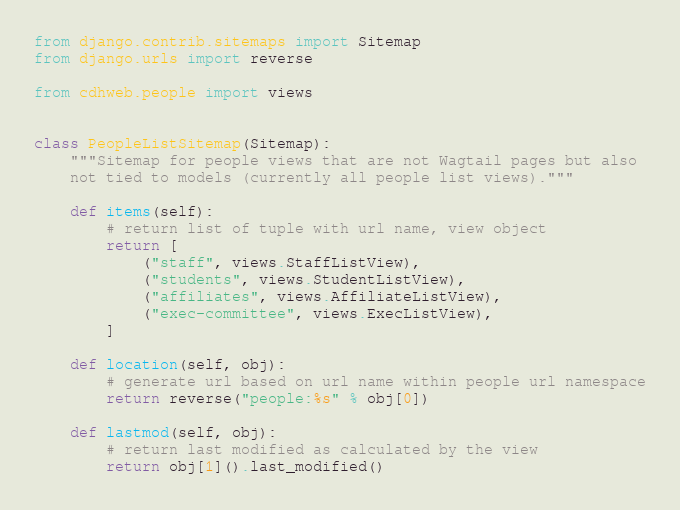Convert code to text. <code><loc_0><loc_0><loc_500><loc_500><_Python_>from django.contrib.sitemaps import Sitemap
from django.urls import reverse

from cdhweb.people import views


class PeopleListSitemap(Sitemap):
    """Sitemap for people views that are not Wagtail pages but also
    not tied to models (currently all people list views)."""

    def items(self):
        # return list of tuple with url name, view object
        return [
            ("staff", views.StaffListView),
            ("students", views.StudentListView),
            ("affiliates", views.AffiliateListView),
            ("exec-committee", views.ExecListView),
        ]

    def location(self, obj):
        # generate url based on url name within people url namespace
        return reverse("people:%s" % obj[0])

    def lastmod(self, obj):
        # return last modified as calculated by the view
        return obj[1]().last_modified()
</code> 